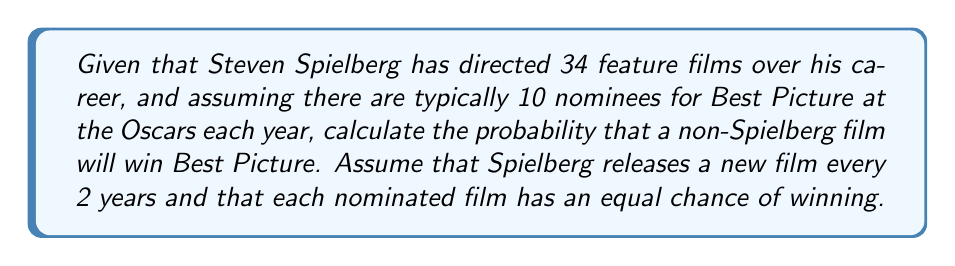Can you solve this math problem? To solve this problem, we need to follow these steps:

1) First, let's calculate how often a Spielberg film is nominated:
   - Spielberg releases a film every 2 years
   - There are 10 nominees each year
   - So, in 2 years, there are 20 nominees, and 1 of them is a Spielberg film

2) The probability of a Spielberg film being nominated is:
   $$ P(\text{Spielberg nominated}) = \frac{1}{20} = 0.05 $$

3) Now, given that a Spielberg film is nominated, we need to calculate the probability that it doesn't win:
   - There are 10 nominees, each with an equal chance of winning
   - So the probability of any nominated film winning is $\frac{1}{10}$

4) Therefore, the probability of a non-Spielberg film winning, given that a Spielberg film is nominated, is:
   $$ P(\text{non-Spielberg wins | Spielberg nominated}) = \frac{9}{10} = 0.9 $$

5) We can now use the law of total probability:
   $$ P(\text{non-Spielberg wins}) = P(\text{non-Spielberg wins | Spielberg nominated}) \times P(\text{Spielberg nominated}) + $$
   $$ P(\text{non-Spielberg wins | Spielberg not nominated}) \times P(\text{Spielberg not nominated}) $$

6) We know:
   - $P(\text{non-Spielberg wins | Spielberg nominated}) = 0.9$
   - $P(\text{Spielberg nominated}) = 0.05$
   - $P(\text{Spielberg not nominated}) = 1 - 0.05 = 0.95$
   - $P(\text{non-Spielberg wins | Spielberg not nominated}) = 1$

7) Plugging these values into the equation:
   $$ P(\text{non-Spielberg wins}) = 0.9 \times 0.05 + 1 \times 0.95 = 0.045 + 0.95 = 0.995 $$
Answer: The probability that a non-Spielberg film will win Best Picture is 0.995 or 99.5%. 